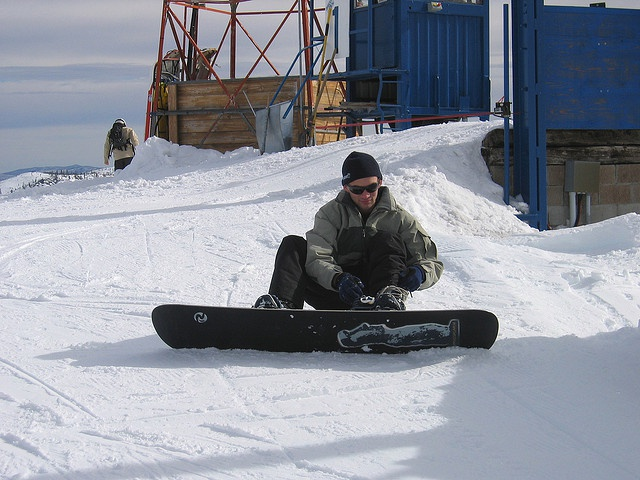Describe the objects in this image and their specific colors. I can see people in darkgray, black, gray, and lightgray tones, snowboard in darkgray, black, gray, and darkblue tones, people in darkgray, black, and gray tones, and backpack in darkgray, black, and gray tones in this image. 